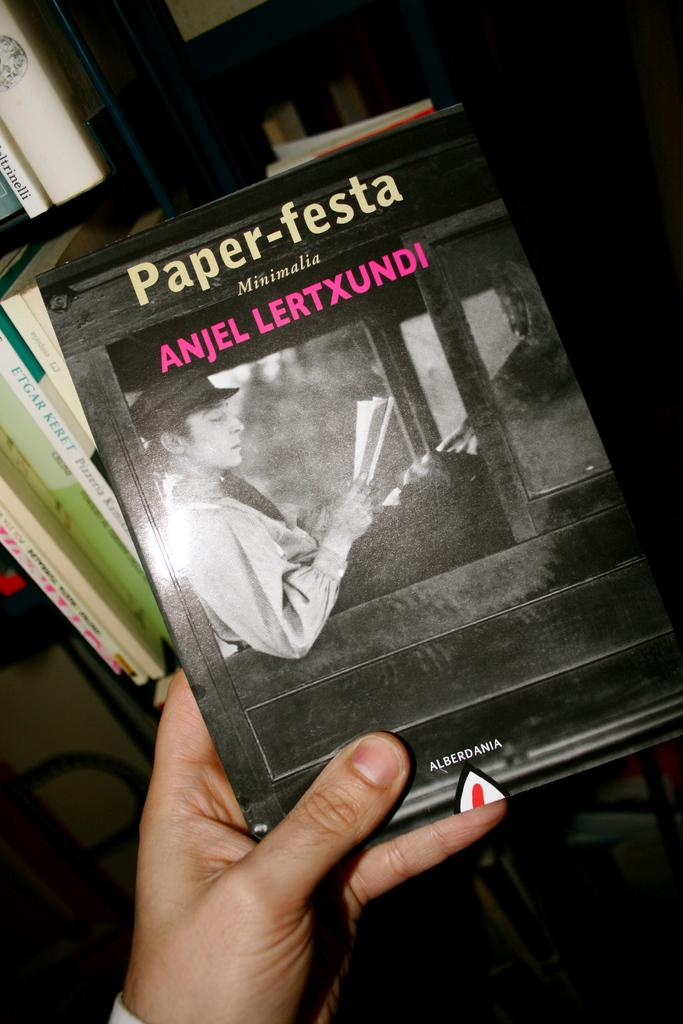What is the person's hand holding in the image? There is a person's hand holding a book in the image. What can be seen in the background of the image? There are racks in the image. What is placed on the racks in the image? There are books placed in the racks in the image. What type of pail is being used to order the books in the image? There is no pail present in the image, and the books are already placed on the racks. 